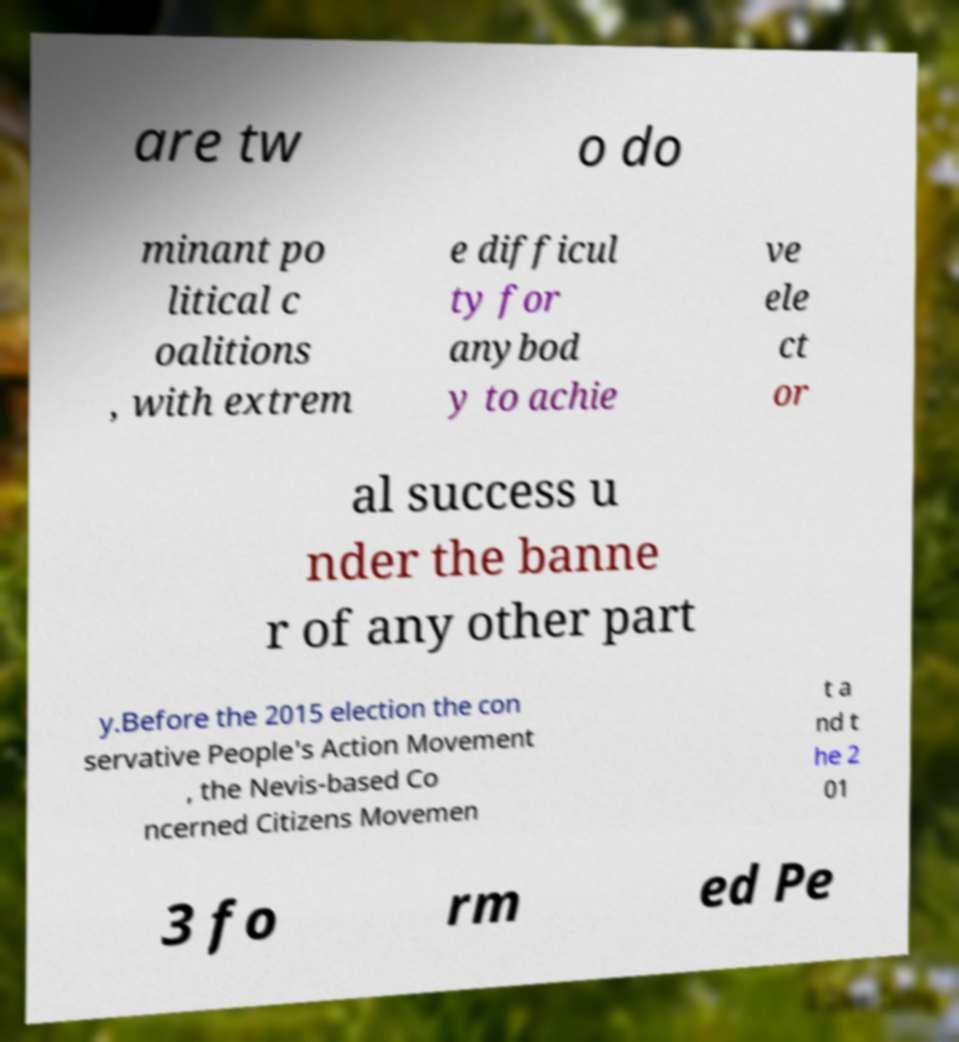Can you read and provide the text displayed in the image?This photo seems to have some interesting text. Can you extract and type it out for me? are tw o do minant po litical c oalitions , with extrem e difficul ty for anybod y to achie ve ele ct or al success u nder the banne r of any other part y.Before the 2015 election the con servative People's Action Movement , the Nevis-based Co ncerned Citizens Movemen t a nd t he 2 01 3 fo rm ed Pe 